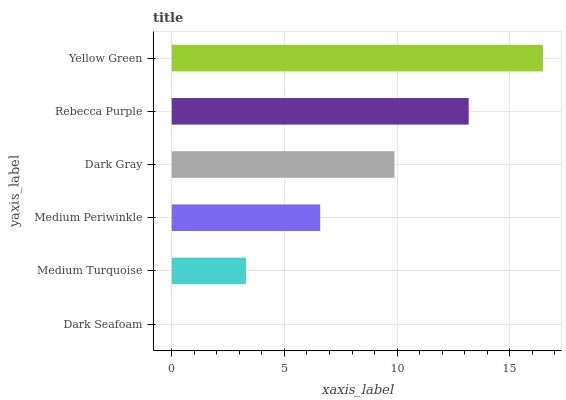Is Dark Seafoam the minimum?
Answer yes or no. Yes. Is Yellow Green the maximum?
Answer yes or no. Yes. Is Medium Turquoise the minimum?
Answer yes or no. No. Is Medium Turquoise the maximum?
Answer yes or no. No. Is Medium Turquoise greater than Dark Seafoam?
Answer yes or no. Yes. Is Dark Seafoam less than Medium Turquoise?
Answer yes or no. Yes. Is Dark Seafoam greater than Medium Turquoise?
Answer yes or no. No. Is Medium Turquoise less than Dark Seafoam?
Answer yes or no. No. Is Dark Gray the high median?
Answer yes or no. Yes. Is Medium Periwinkle the low median?
Answer yes or no. Yes. Is Medium Periwinkle the high median?
Answer yes or no. No. Is Medium Turquoise the low median?
Answer yes or no. No. 